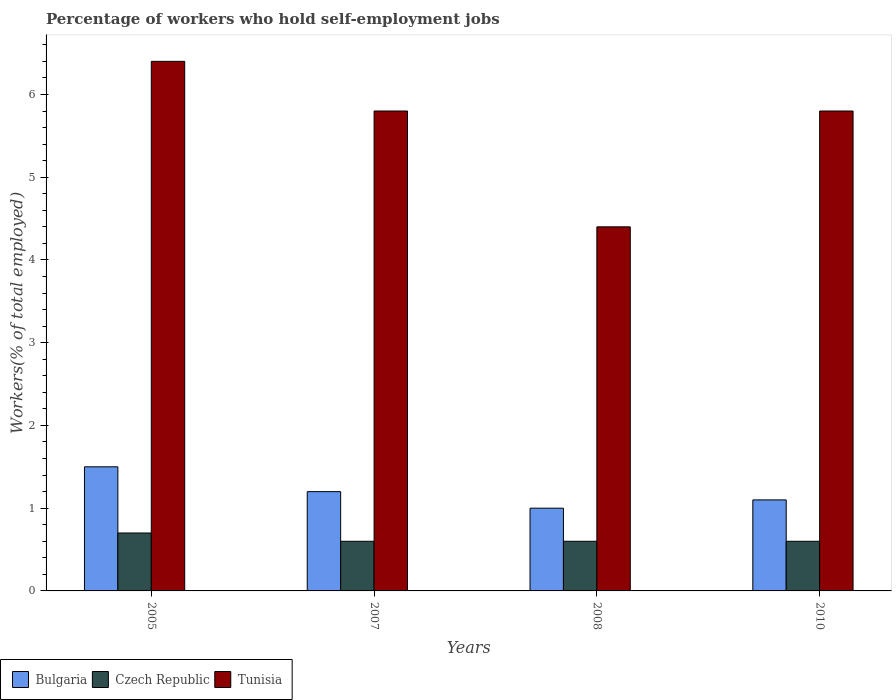How many different coloured bars are there?
Give a very brief answer. 3. How many groups of bars are there?
Provide a succinct answer. 4. How many bars are there on the 4th tick from the left?
Provide a short and direct response. 3. How many bars are there on the 1st tick from the right?
Provide a short and direct response. 3. What is the label of the 3rd group of bars from the left?
Offer a terse response. 2008. In how many cases, is the number of bars for a given year not equal to the number of legend labels?
Offer a terse response. 0. What is the percentage of self-employed workers in Tunisia in 2010?
Your response must be concise. 5.8. Across all years, what is the maximum percentage of self-employed workers in Tunisia?
Keep it short and to the point. 6.4. Across all years, what is the minimum percentage of self-employed workers in Tunisia?
Your answer should be compact. 4.4. In which year was the percentage of self-employed workers in Tunisia minimum?
Your answer should be compact. 2008. What is the total percentage of self-employed workers in Tunisia in the graph?
Ensure brevity in your answer.  22.4. What is the difference between the percentage of self-employed workers in Bulgaria in 2005 and that in 2007?
Ensure brevity in your answer.  0.3. What is the difference between the percentage of self-employed workers in Czech Republic in 2010 and the percentage of self-employed workers in Tunisia in 2005?
Your response must be concise. -5.8. What is the average percentage of self-employed workers in Czech Republic per year?
Provide a short and direct response. 0.63. In the year 2008, what is the difference between the percentage of self-employed workers in Tunisia and percentage of self-employed workers in Bulgaria?
Your response must be concise. 3.4. What is the ratio of the percentage of self-employed workers in Tunisia in 2008 to that in 2010?
Provide a short and direct response. 0.76. Is the percentage of self-employed workers in Tunisia in 2005 less than that in 2007?
Your response must be concise. No. Is the difference between the percentage of self-employed workers in Tunisia in 2007 and 2010 greater than the difference between the percentage of self-employed workers in Bulgaria in 2007 and 2010?
Provide a short and direct response. No. What is the difference between the highest and the second highest percentage of self-employed workers in Tunisia?
Offer a very short reply. 0.6. What is the difference between the highest and the lowest percentage of self-employed workers in Czech Republic?
Offer a very short reply. 0.1. Is the sum of the percentage of self-employed workers in Czech Republic in 2005 and 2007 greater than the maximum percentage of self-employed workers in Bulgaria across all years?
Make the answer very short. No. What does the 2nd bar from the left in 2005 represents?
Keep it short and to the point. Czech Republic. What does the 2nd bar from the right in 2008 represents?
Keep it short and to the point. Czech Republic. Is it the case that in every year, the sum of the percentage of self-employed workers in Bulgaria and percentage of self-employed workers in Tunisia is greater than the percentage of self-employed workers in Czech Republic?
Provide a succinct answer. Yes. How many bars are there?
Your answer should be compact. 12. How many years are there in the graph?
Provide a succinct answer. 4. Are the values on the major ticks of Y-axis written in scientific E-notation?
Offer a terse response. No. Where does the legend appear in the graph?
Your response must be concise. Bottom left. What is the title of the graph?
Make the answer very short. Percentage of workers who hold self-employment jobs. What is the label or title of the Y-axis?
Your answer should be compact. Workers(% of total employed). What is the Workers(% of total employed) of Czech Republic in 2005?
Make the answer very short. 0.7. What is the Workers(% of total employed) of Tunisia in 2005?
Your response must be concise. 6.4. What is the Workers(% of total employed) in Bulgaria in 2007?
Give a very brief answer. 1.2. What is the Workers(% of total employed) in Czech Republic in 2007?
Offer a very short reply. 0.6. What is the Workers(% of total employed) of Tunisia in 2007?
Your answer should be compact. 5.8. What is the Workers(% of total employed) in Bulgaria in 2008?
Make the answer very short. 1. What is the Workers(% of total employed) in Czech Republic in 2008?
Offer a very short reply. 0.6. What is the Workers(% of total employed) in Tunisia in 2008?
Keep it short and to the point. 4.4. What is the Workers(% of total employed) in Bulgaria in 2010?
Offer a terse response. 1.1. What is the Workers(% of total employed) of Czech Republic in 2010?
Your answer should be very brief. 0.6. What is the Workers(% of total employed) in Tunisia in 2010?
Provide a succinct answer. 5.8. Across all years, what is the maximum Workers(% of total employed) of Bulgaria?
Provide a short and direct response. 1.5. Across all years, what is the maximum Workers(% of total employed) in Czech Republic?
Give a very brief answer. 0.7. Across all years, what is the maximum Workers(% of total employed) of Tunisia?
Make the answer very short. 6.4. Across all years, what is the minimum Workers(% of total employed) of Bulgaria?
Make the answer very short. 1. Across all years, what is the minimum Workers(% of total employed) of Czech Republic?
Offer a terse response. 0.6. Across all years, what is the minimum Workers(% of total employed) of Tunisia?
Offer a terse response. 4.4. What is the total Workers(% of total employed) of Bulgaria in the graph?
Provide a succinct answer. 4.8. What is the total Workers(% of total employed) in Czech Republic in the graph?
Offer a terse response. 2.5. What is the total Workers(% of total employed) of Tunisia in the graph?
Your response must be concise. 22.4. What is the difference between the Workers(% of total employed) of Bulgaria in 2005 and that in 2007?
Your response must be concise. 0.3. What is the difference between the Workers(% of total employed) in Czech Republic in 2005 and that in 2007?
Offer a terse response. 0.1. What is the difference between the Workers(% of total employed) of Bulgaria in 2005 and that in 2008?
Your response must be concise. 0.5. What is the difference between the Workers(% of total employed) of Bulgaria in 2007 and that in 2008?
Make the answer very short. 0.2. What is the difference between the Workers(% of total employed) in Bulgaria in 2007 and that in 2010?
Your response must be concise. 0.1. What is the difference between the Workers(% of total employed) in Czech Republic in 2007 and that in 2010?
Your answer should be very brief. 0. What is the difference between the Workers(% of total employed) in Tunisia in 2007 and that in 2010?
Make the answer very short. 0. What is the difference between the Workers(% of total employed) of Bulgaria in 2008 and that in 2010?
Give a very brief answer. -0.1. What is the difference between the Workers(% of total employed) of Bulgaria in 2005 and the Workers(% of total employed) of Czech Republic in 2007?
Provide a succinct answer. 0.9. What is the difference between the Workers(% of total employed) in Bulgaria in 2005 and the Workers(% of total employed) in Tunisia in 2007?
Your answer should be very brief. -4.3. What is the difference between the Workers(% of total employed) of Czech Republic in 2005 and the Workers(% of total employed) of Tunisia in 2007?
Your answer should be compact. -5.1. What is the difference between the Workers(% of total employed) in Czech Republic in 2005 and the Workers(% of total employed) in Tunisia in 2008?
Offer a terse response. -3.7. What is the difference between the Workers(% of total employed) in Bulgaria in 2005 and the Workers(% of total employed) in Czech Republic in 2010?
Your response must be concise. 0.9. What is the difference between the Workers(% of total employed) in Bulgaria in 2005 and the Workers(% of total employed) in Tunisia in 2010?
Your response must be concise. -4.3. What is the difference between the Workers(% of total employed) of Czech Republic in 2005 and the Workers(% of total employed) of Tunisia in 2010?
Make the answer very short. -5.1. What is the difference between the Workers(% of total employed) of Bulgaria in 2007 and the Workers(% of total employed) of Tunisia in 2008?
Provide a short and direct response. -3.2. What is the difference between the Workers(% of total employed) in Czech Republic in 2007 and the Workers(% of total employed) in Tunisia in 2008?
Your answer should be compact. -3.8. What is the difference between the Workers(% of total employed) in Bulgaria in 2007 and the Workers(% of total employed) in Czech Republic in 2010?
Your answer should be very brief. 0.6. What is the difference between the Workers(% of total employed) of Bulgaria in 2007 and the Workers(% of total employed) of Tunisia in 2010?
Provide a short and direct response. -4.6. What is the difference between the Workers(% of total employed) in Czech Republic in 2007 and the Workers(% of total employed) in Tunisia in 2010?
Your response must be concise. -5.2. What is the difference between the Workers(% of total employed) in Bulgaria in 2008 and the Workers(% of total employed) in Czech Republic in 2010?
Offer a very short reply. 0.4. What is the difference between the Workers(% of total employed) in Czech Republic in 2008 and the Workers(% of total employed) in Tunisia in 2010?
Provide a short and direct response. -5.2. In the year 2005, what is the difference between the Workers(% of total employed) of Bulgaria and Workers(% of total employed) of Czech Republic?
Give a very brief answer. 0.8. In the year 2005, what is the difference between the Workers(% of total employed) in Bulgaria and Workers(% of total employed) in Tunisia?
Provide a short and direct response. -4.9. In the year 2005, what is the difference between the Workers(% of total employed) of Czech Republic and Workers(% of total employed) of Tunisia?
Give a very brief answer. -5.7. In the year 2007, what is the difference between the Workers(% of total employed) in Bulgaria and Workers(% of total employed) in Czech Republic?
Provide a short and direct response. 0.6. In the year 2007, what is the difference between the Workers(% of total employed) of Bulgaria and Workers(% of total employed) of Tunisia?
Ensure brevity in your answer.  -4.6. In the year 2008, what is the difference between the Workers(% of total employed) in Bulgaria and Workers(% of total employed) in Czech Republic?
Provide a succinct answer. 0.4. In the year 2008, what is the difference between the Workers(% of total employed) of Bulgaria and Workers(% of total employed) of Tunisia?
Your response must be concise. -3.4. In the year 2008, what is the difference between the Workers(% of total employed) of Czech Republic and Workers(% of total employed) of Tunisia?
Give a very brief answer. -3.8. In the year 2010, what is the difference between the Workers(% of total employed) of Bulgaria and Workers(% of total employed) of Czech Republic?
Provide a succinct answer. 0.5. In the year 2010, what is the difference between the Workers(% of total employed) in Bulgaria and Workers(% of total employed) in Tunisia?
Offer a very short reply. -4.7. In the year 2010, what is the difference between the Workers(% of total employed) of Czech Republic and Workers(% of total employed) of Tunisia?
Your answer should be compact. -5.2. What is the ratio of the Workers(% of total employed) of Bulgaria in 2005 to that in 2007?
Ensure brevity in your answer.  1.25. What is the ratio of the Workers(% of total employed) of Czech Republic in 2005 to that in 2007?
Your answer should be compact. 1.17. What is the ratio of the Workers(% of total employed) of Tunisia in 2005 to that in 2007?
Offer a very short reply. 1.1. What is the ratio of the Workers(% of total employed) in Bulgaria in 2005 to that in 2008?
Your response must be concise. 1.5. What is the ratio of the Workers(% of total employed) in Czech Republic in 2005 to that in 2008?
Your response must be concise. 1.17. What is the ratio of the Workers(% of total employed) in Tunisia in 2005 to that in 2008?
Keep it short and to the point. 1.45. What is the ratio of the Workers(% of total employed) in Bulgaria in 2005 to that in 2010?
Your response must be concise. 1.36. What is the ratio of the Workers(% of total employed) in Tunisia in 2005 to that in 2010?
Provide a short and direct response. 1.1. What is the ratio of the Workers(% of total employed) of Tunisia in 2007 to that in 2008?
Offer a terse response. 1.32. What is the ratio of the Workers(% of total employed) in Bulgaria in 2007 to that in 2010?
Keep it short and to the point. 1.09. What is the ratio of the Workers(% of total employed) of Bulgaria in 2008 to that in 2010?
Your response must be concise. 0.91. What is the ratio of the Workers(% of total employed) of Czech Republic in 2008 to that in 2010?
Provide a short and direct response. 1. What is the ratio of the Workers(% of total employed) of Tunisia in 2008 to that in 2010?
Make the answer very short. 0.76. What is the difference between the highest and the second highest Workers(% of total employed) in Bulgaria?
Offer a terse response. 0.3. What is the difference between the highest and the second highest Workers(% of total employed) of Czech Republic?
Your answer should be very brief. 0.1. 